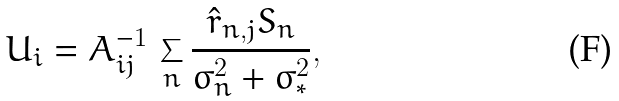Convert formula to latex. <formula><loc_0><loc_0><loc_500><loc_500>U _ { i } = A _ { i j } ^ { - 1 } \, \sum _ { n } \frac { \hat { r } _ { n , j } S _ { n } } { \sigma _ { n } ^ { 2 } + \sigma _ { * } ^ { 2 } } ,</formula> 